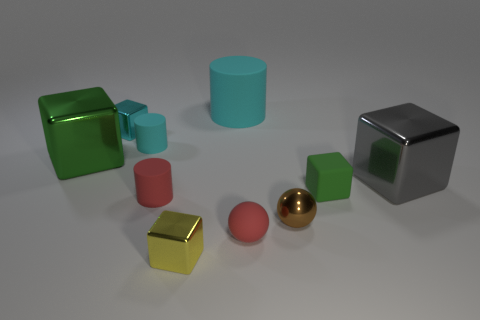Subtract all blue spheres. How many green cubes are left? 2 Subtract all tiny cyan cubes. How many cubes are left? 4 Subtract all cyan cubes. How many cubes are left? 4 Subtract all balls. How many objects are left? 8 Subtract 0 gray cylinders. How many objects are left? 10 Subtract all blue cubes. Subtract all cyan cylinders. How many cubes are left? 5 Subtract all red metallic cylinders. Subtract all tiny objects. How many objects are left? 3 Add 4 small yellow metallic blocks. How many small yellow metallic blocks are left? 5 Add 8 red cylinders. How many red cylinders exist? 9 